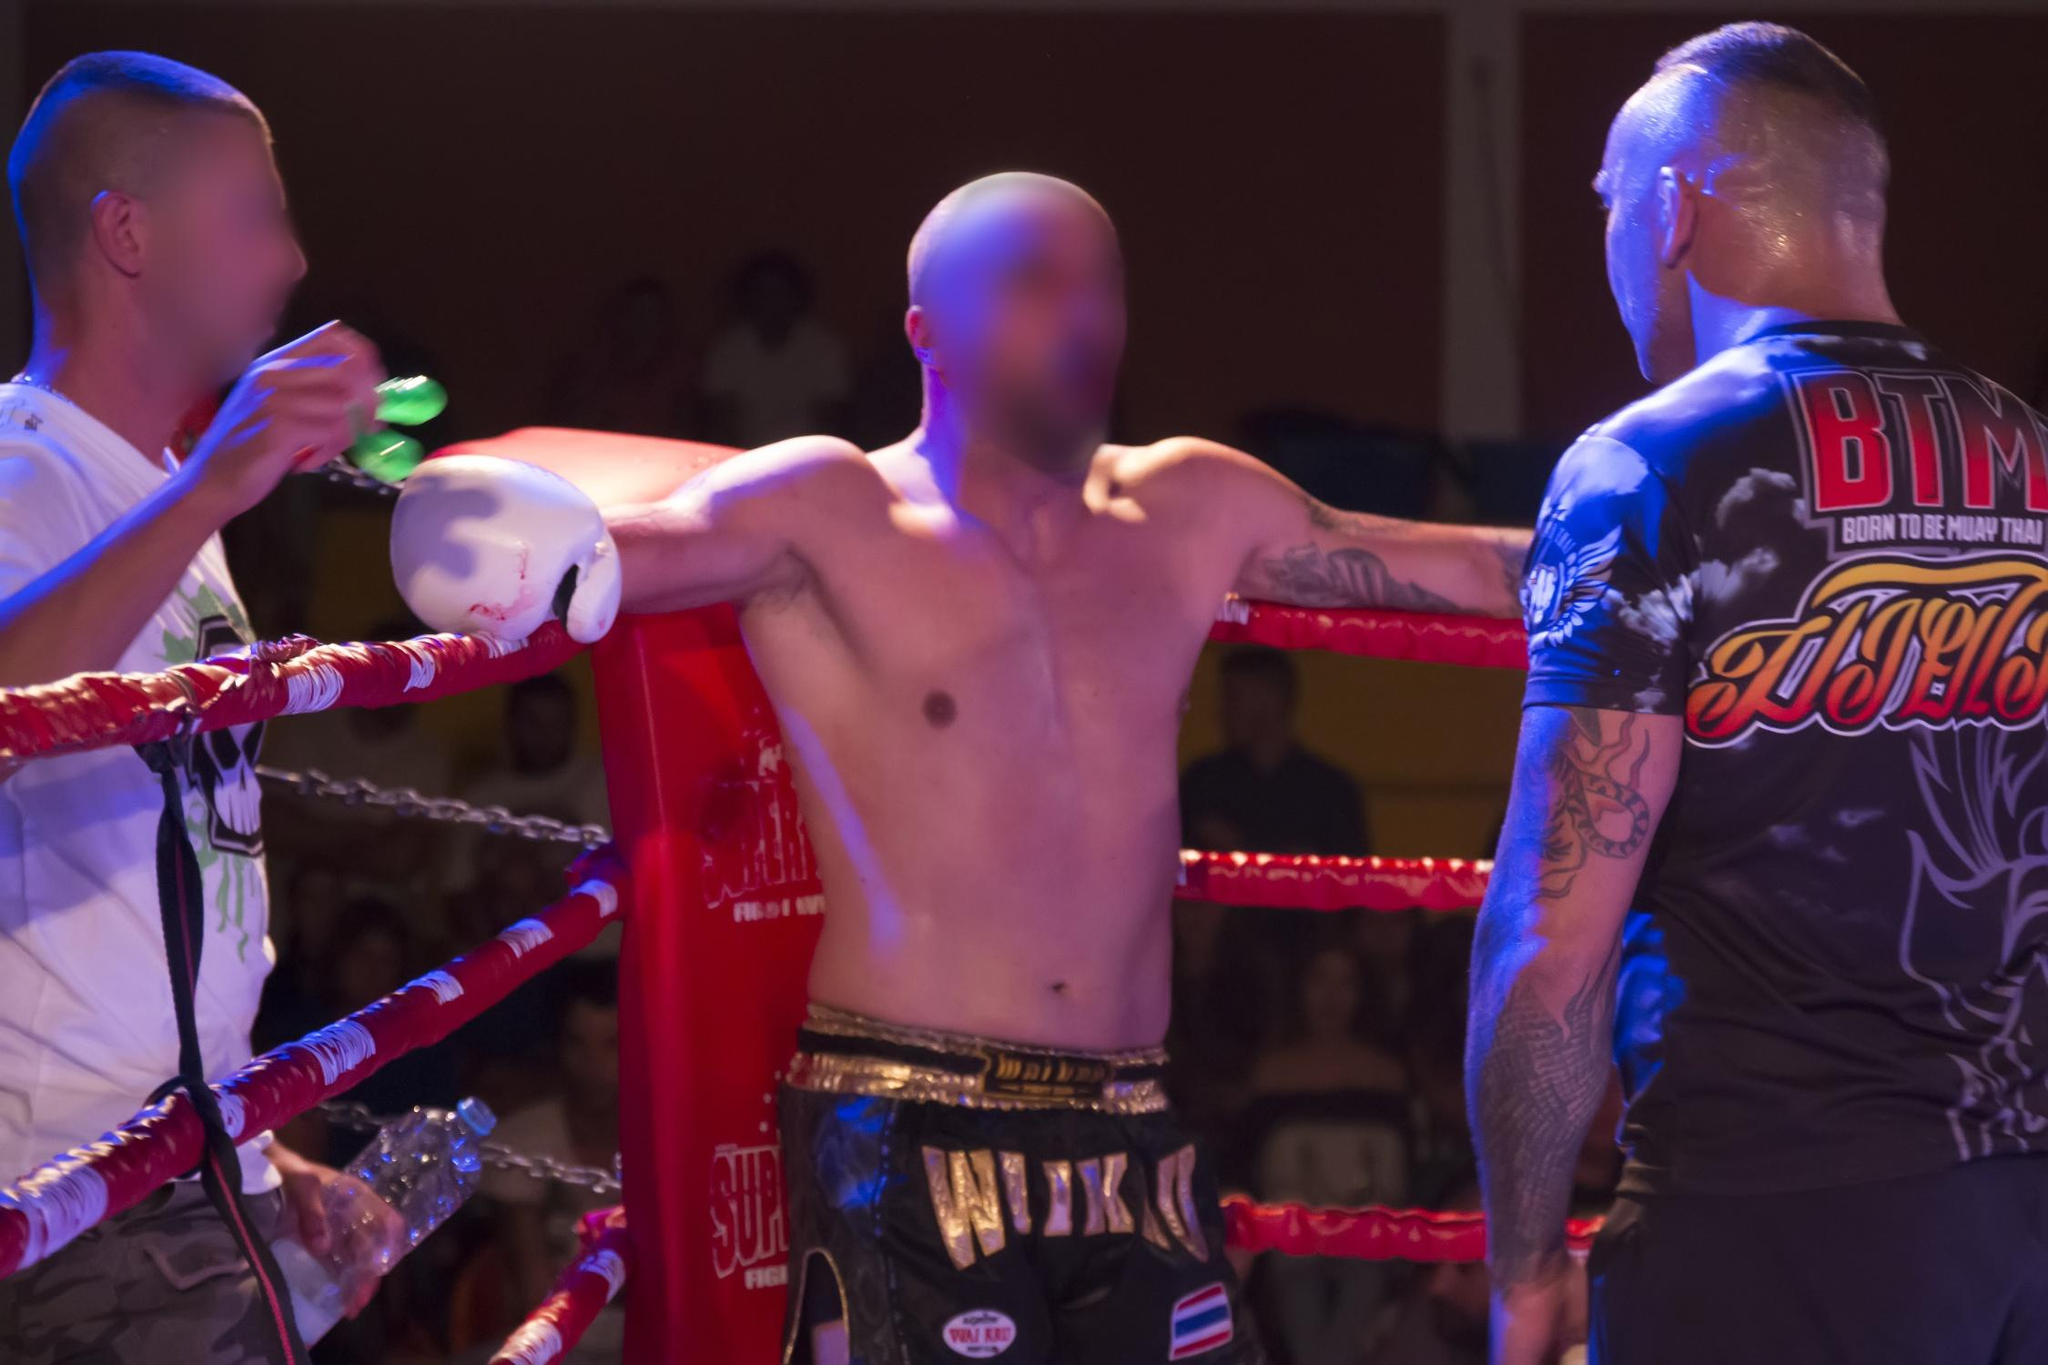Analyze the image in a comprehensive and detailed manner. The image captures a dynamic scene of a boxing match. The perspective is from the audience's viewpoint, giving a sense of being part of the action. In the ring, three figures are visible, two of whom are the main focus. They are dressed in boxing attire, complete with gloves, and are engaged in a fight. One of them is slightly blurred, suggesting movement and the fast-paced nature of the sport. The background is filled with the blurred shapes of the audience, adding depth to the image and emphasizing the public nature of the event. The ropes of the boxing ring frame the scene, providing a boundary for the action. The colors in the image are predominantly red and blue, possibly reflecting the colors of the boxers' attire or the lighting in the venue. The landmark identifier "sa_16637" doesn't provide additional information about the location or event in the image. 